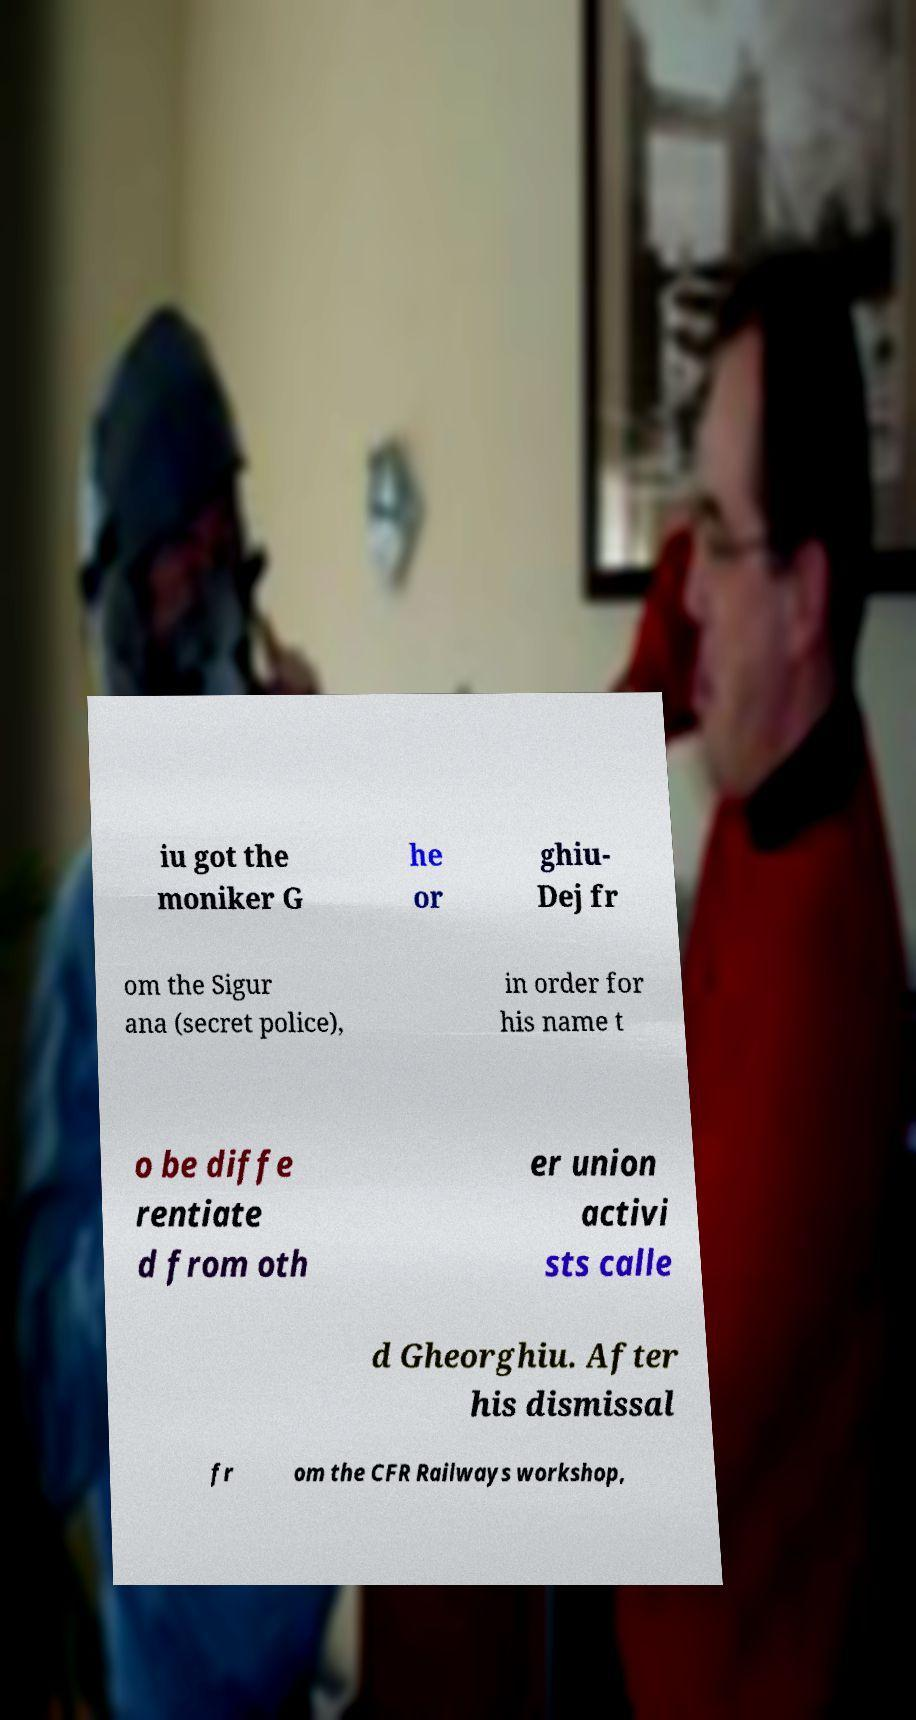There's text embedded in this image that I need extracted. Can you transcribe it verbatim? iu got the moniker G he or ghiu- Dej fr om the Sigur ana (secret police), in order for his name t o be diffe rentiate d from oth er union activi sts calle d Gheorghiu. After his dismissal fr om the CFR Railways workshop, 